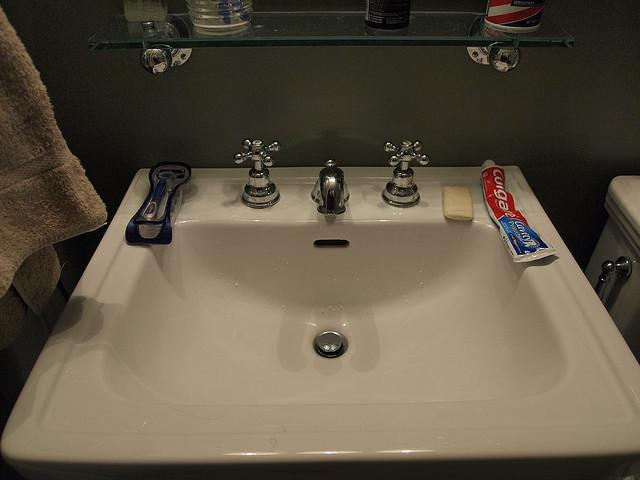What will they squeeze the substance in the tube onto?

Choices:
A) onto washcloth
B) toothbrush
C) into sink
D) onto soap toothbrush 